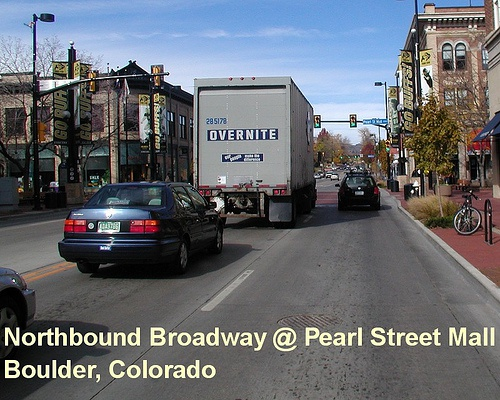Describe the objects in this image and their specific colors. I can see truck in darkgray, black, gray, and lightgray tones, car in darkgray, black, gray, navy, and blue tones, car in darkgray, black, gray, beige, and khaki tones, car in darkgray, black, gray, purple, and maroon tones, and bicycle in darkgray, black, and gray tones in this image. 